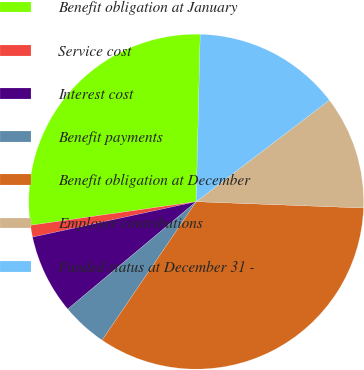Convert chart. <chart><loc_0><loc_0><loc_500><loc_500><pie_chart><fcel>Benefit obligation at January<fcel>Service cost<fcel>Interest cost<fcel>Benefit payments<fcel>Benefit obligation at December<fcel>Employer contributions<fcel>Funded status at December 31 -<nl><fcel>27.64%<fcel>1.14%<fcel>7.69%<fcel>4.42%<fcel>33.9%<fcel>10.97%<fcel>14.25%<nl></chart> 